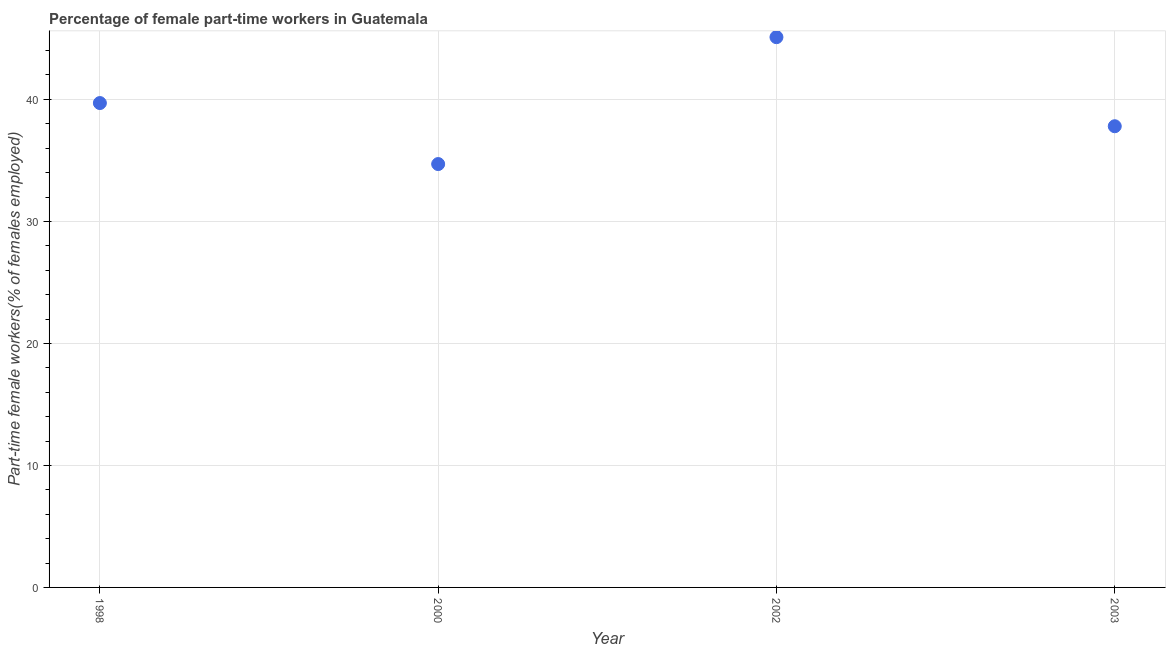What is the percentage of part-time female workers in 1998?
Keep it short and to the point. 39.7. Across all years, what is the maximum percentage of part-time female workers?
Keep it short and to the point. 45.1. Across all years, what is the minimum percentage of part-time female workers?
Provide a short and direct response. 34.7. What is the sum of the percentage of part-time female workers?
Keep it short and to the point. 157.3. What is the difference between the percentage of part-time female workers in 2000 and 2003?
Ensure brevity in your answer.  -3.1. What is the average percentage of part-time female workers per year?
Provide a succinct answer. 39.32. What is the median percentage of part-time female workers?
Your answer should be compact. 38.75. In how many years, is the percentage of part-time female workers greater than 4 %?
Keep it short and to the point. 4. Do a majority of the years between 2000 and 2003 (inclusive) have percentage of part-time female workers greater than 42 %?
Provide a succinct answer. No. What is the ratio of the percentage of part-time female workers in 2002 to that in 2003?
Provide a short and direct response. 1.19. Is the percentage of part-time female workers in 2000 less than that in 2003?
Ensure brevity in your answer.  Yes. What is the difference between the highest and the second highest percentage of part-time female workers?
Your response must be concise. 5.4. Is the sum of the percentage of part-time female workers in 1998 and 2000 greater than the maximum percentage of part-time female workers across all years?
Your response must be concise. Yes. What is the difference between the highest and the lowest percentage of part-time female workers?
Provide a short and direct response. 10.4. In how many years, is the percentage of part-time female workers greater than the average percentage of part-time female workers taken over all years?
Ensure brevity in your answer.  2. Does the percentage of part-time female workers monotonically increase over the years?
Your response must be concise. No. How many years are there in the graph?
Ensure brevity in your answer.  4. What is the difference between two consecutive major ticks on the Y-axis?
Provide a succinct answer. 10. Does the graph contain grids?
Your response must be concise. Yes. What is the title of the graph?
Provide a short and direct response. Percentage of female part-time workers in Guatemala. What is the label or title of the X-axis?
Your response must be concise. Year. What is the label or title of the Y-axis?
Give a very brief answer. Part-time female workers(% of females employed). What is the Part-time female workers(% of females employed) in 1998?
Keep it short and to the point. 39.7. What is the Part-time female workers(% of females employed) in 2000?
Provide a short and direct response. 34.7. What is the Part-time female workers(% of females employed) in 2002?
Offer a very short reply. 45.1. What is the Part-time female workers(% of females employed) in 2003?
Offer a very short reply. 37.8. What is the difference between the Part-time female workers(% of females employed) in 1998 and 2000?
Ensure brevity in your answer.  5. What is the difference between the Part-time female workers(% of females employed) in 1998 and 2003?
Ensure brevity in your answer.  1.9. What is the difference between the Part-time female workers(% of females employed) in 2000 and 2003?
Offer a terse response. -3.1. What is the difference between the Part-time female workers(% of females employed) in 2002 and 2003?
Offer a very short reply. 7.3. What is the ratio of the Part-time female workers(% of females employed) in 1998 to that in 2000?
Make the answer very short. 1.14. What is the ratio of the Part-time female workers(% of females employed) in 1998 to that in 2002?
Your answer should be compact. 0.88. What is the ratio of the Part-time female workers(% of females employed) in 2000 to that in 2002?
Make the answer very short. 0.77. What is the ratio of the Part-time female workers(% of females employed) in 2000 to that in 2003?
Provide a short and direct response. 0.92. What is the ratio of the Part-time female workers(% of females employed) in 2002 to that in 2003?
Provide a succinct answer. 1.19. 